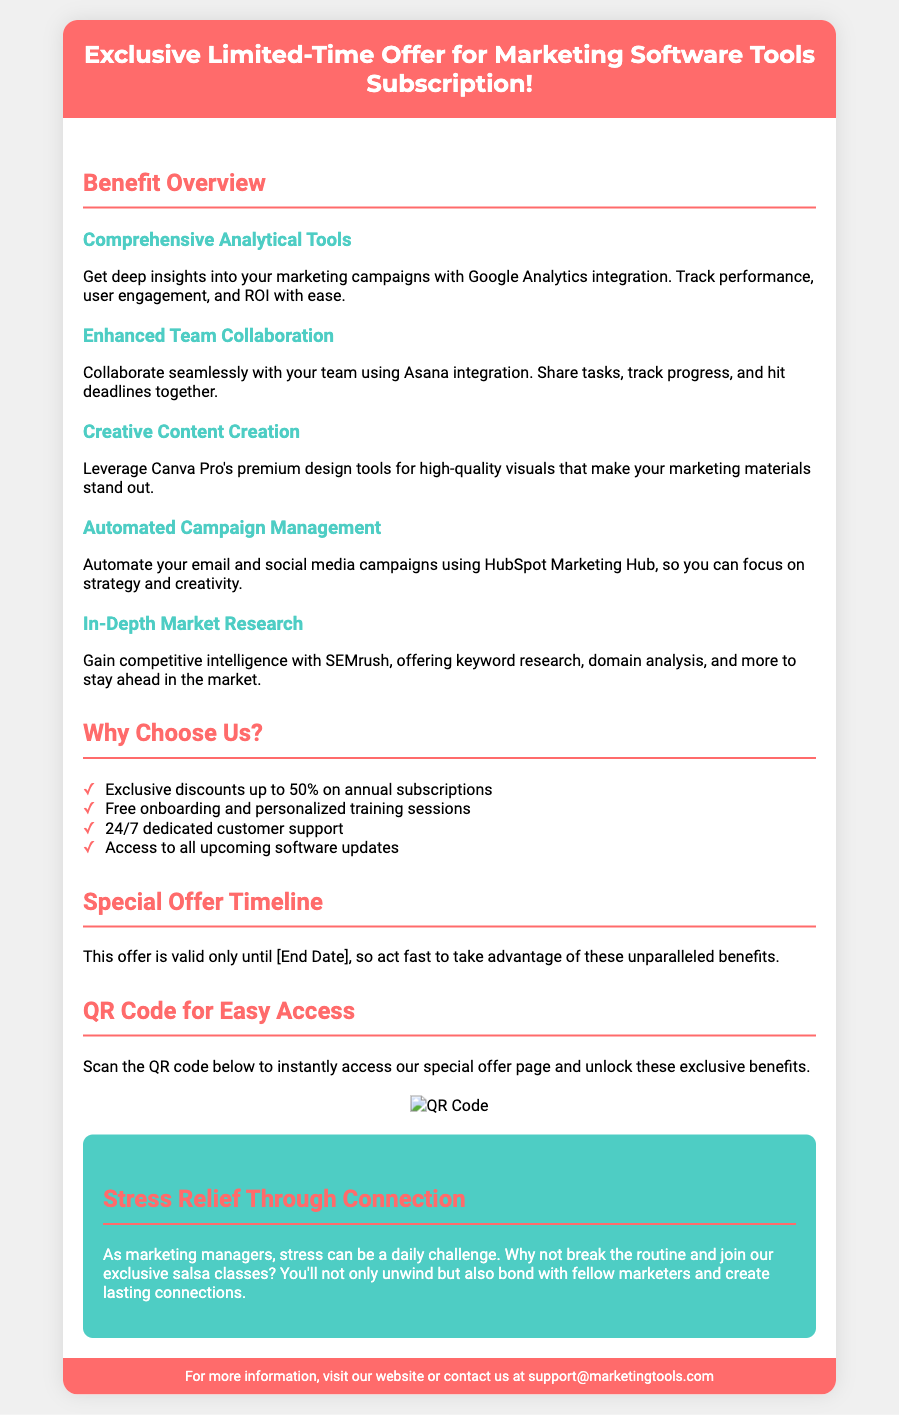What is the offer type? The document is promoting an exclusive limited-time offer for marketing software tools subscription.
Answer: Exclusive Limited-Time Offer What is the main benefit of using Google Analytics? It provides deep insights into marketing campaigns, tracking performance, user engagement, and ROI.
Answer: Deep insights into marketing campaigns What is the discount percentage offered on annual subscriptions? The document mentions exclusive discounts of up to 50% on annual subscriptions.
Answer: Up to 50% What is included in the special offer timeline? The offer is valid until a specified end date, prompting readers to act fast.
Answer: Valid until [End Date] What service is mentioned for automated campaign management? The document refers to using HubSpot Marketing Hub for automating email and social media campaigns.
Answer: HubSpot Marketing Hub What solution does the document suggest for creative content creation? It mentions leveraging Canva Pro's premium design tools for high-quality visuals.
Answer: Canva Pro How does the document suggest relieving stress? It encourages joining exclusive salsa classes to unwind and bond with colleagues.
Answer: Salsa classes What type of support is offered according to the document? The document states that there is 24/7 dedicated customer support available.
Answer: 24/7 dedicated customer support 